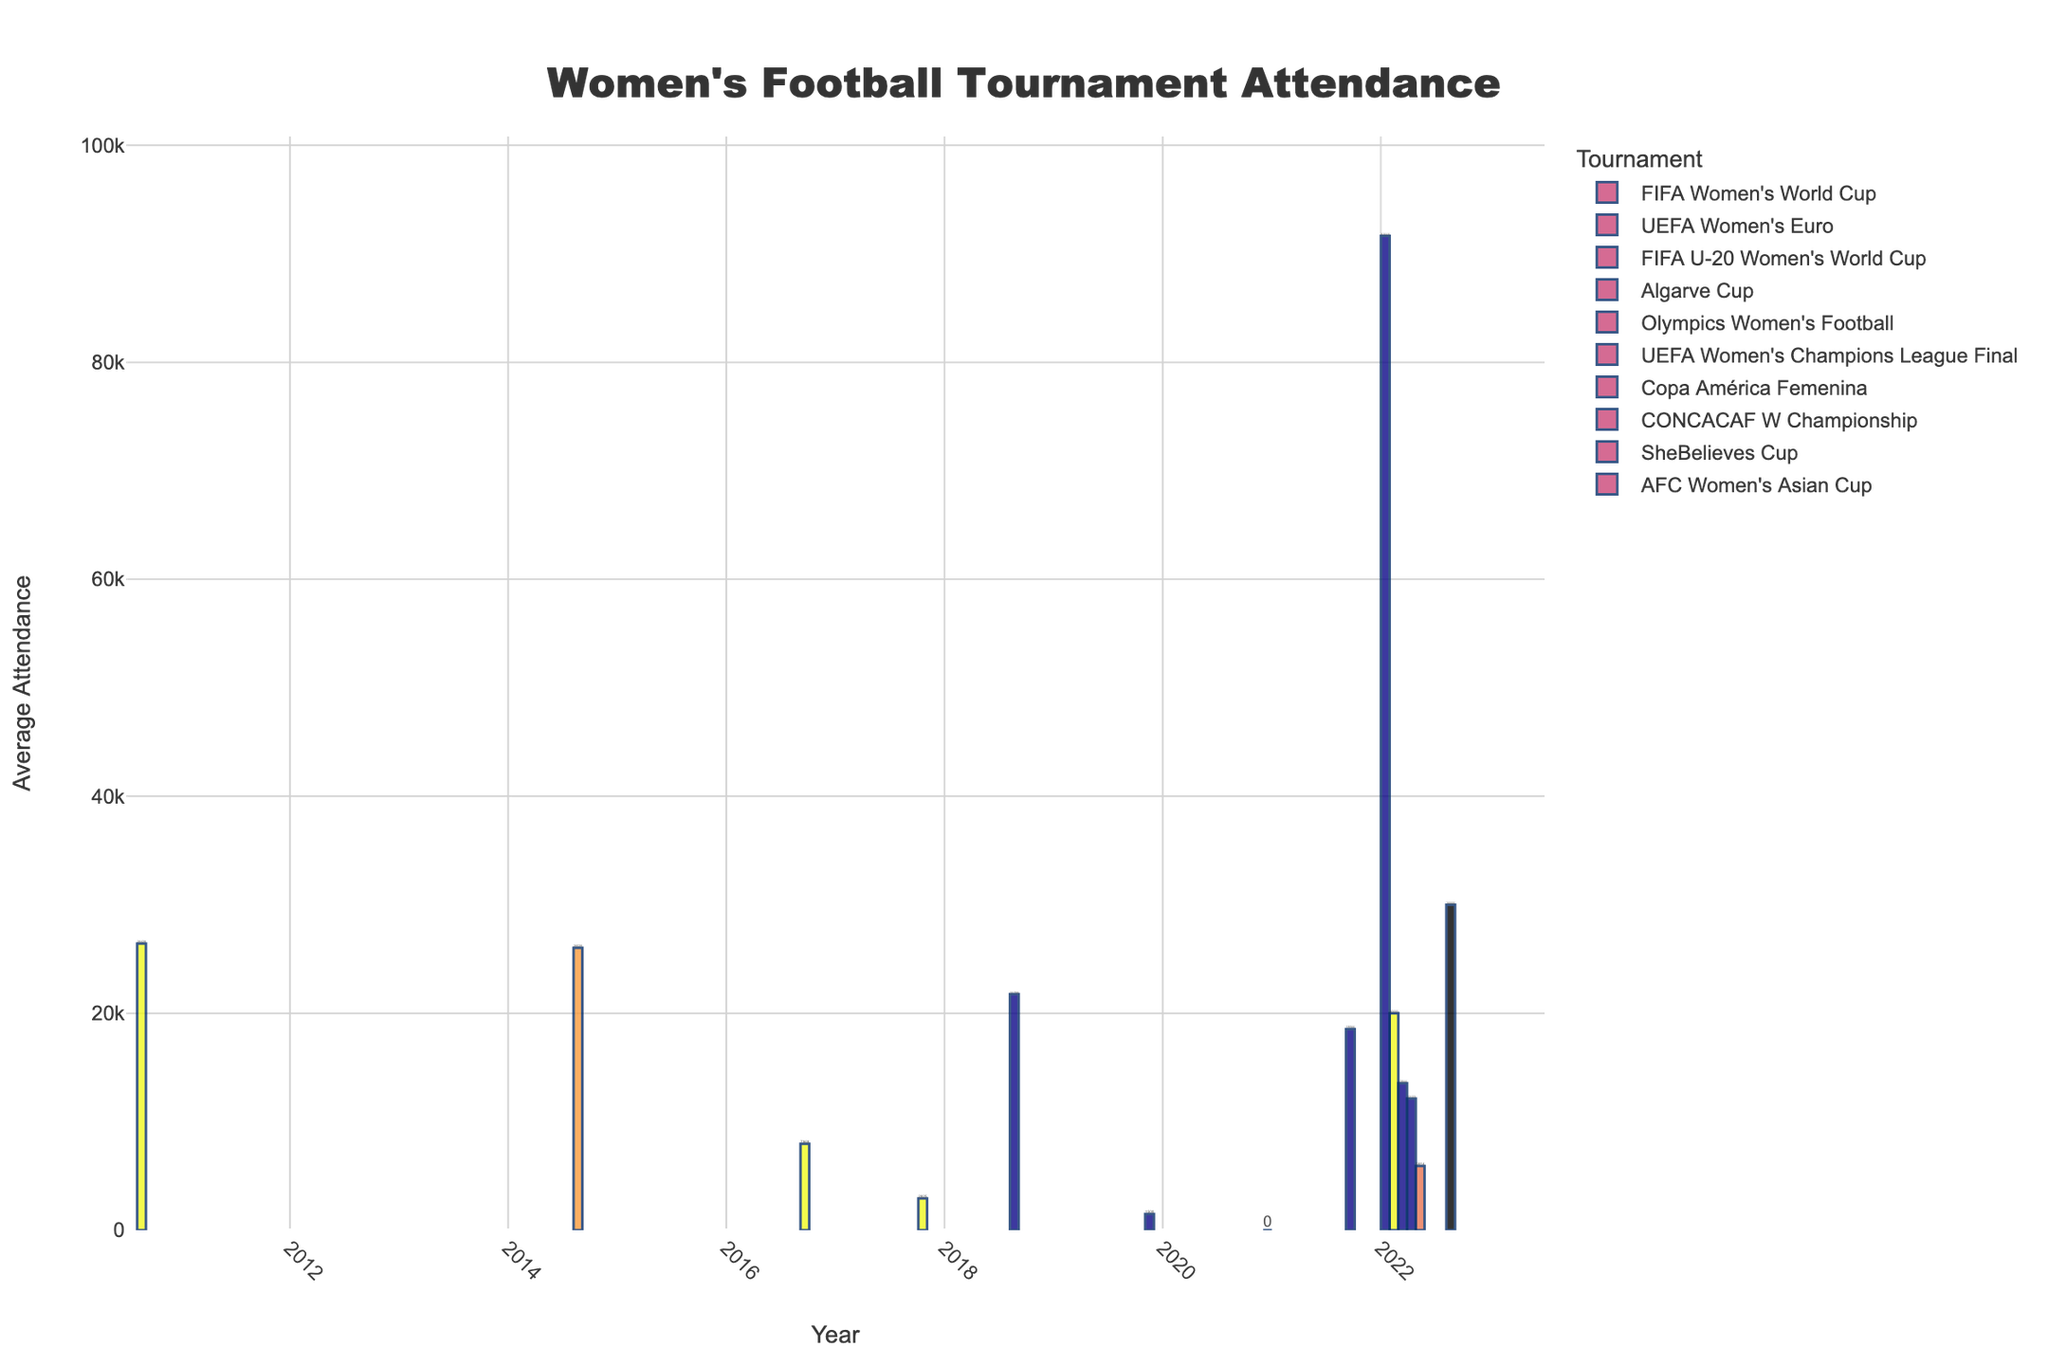What's the highest average attendance for any tournament? Look at the bar with the greatest height, representing the top attendance figure. From the figure, the highest bar corresponds to the UEFA Women's Champions League Final, 2022, with an average attendance of 91,648.
Answer: 91,648 Between the FIFA Women's World Cup 2015 and 2019, which had a higher average attendance, and by how much? Compare the heights of the bars for FIFA Women's World Cup 2015 and 2019. The 2015 bar is slightly higher than the 2019 bar. Subtract their values: 26,029 (2015) - 21,756 (2019)
Answer: FIFA Women's World Cup 2015 had 4,273 more attendees than in 2019 What was the average attendance for the Copa América Femenina, 2022? Identify the bar labeled "Copa América Femenina" under the year 2022 and read its height, which represents the average attendance.
Answer: 20,000 Which tournament had the lowest average attendance? Identify the shortest bar on the figure. The shortest bar corresponds to the Algarve Cup, 2020, with an average attendance of 1,500.
Answer: Algarve Cup, 2020 In 2022, which tournament had the third lowest average attendance and what was the figure? First, isolate all tournaments in 2022. Then, sort their attendance figures and find the third smallest one. Starting from the lowest: AFC Women's Asian Cup (5,914), Algarve Cup (1,500), SheBelieves Cup (12,123).
Answer: SheBelieves Cup, 12,123 What was the average attendance for the AFC Women's Asian Cup, 2022, and the FIFA U-20 Women's World Cup, 2018 combined? Locate the bars for AFC Women's Asian Cup, 2022 and FIFA U-20 Women's World Cup, 2018 and add their values together: 5,914 (AFC Women's Asian Cup, 2022) + 2,925 (FIFA U-20 Women's World Cup, 2018)
Answer: 8,839 Which year had the highest average attendance across all tournaments? Compare the total of average attendances for each year by scanning all bars in each year. 2022 had the most attendances: UEFA Women's Champions League Final (91,648), UEFA Women's Euro (18,544), CONCACAF W Championship (13,544), Copa América Femenina (20,000), AFC Women's Asian Cup (5,914), SheBelieves Cup (12,123),  2022 combined: 161,773.
Answer: 2022 Are there any tournaments that recorded zero attendance? Yes, check if any bars have a height of zero. The Olympics Women's Football, 2021 had zero attendance.
Answer: Olympics Women's Football, 2021 How does the attendance for the UEFA Women's Euro in 2022 compare to its previous tournament in 2017? Compare the heights of the bars for UEFA Women's Euro in 2022 and 2017. The 2022 bar is significantly higher than the 2017 bar.
Answer: Attendance increased in 2022 Summarize the overall trend in attendance for the FIFA Women's World Cup from 2011 to 2023. Observe the height change of the bars for FIFA Women's World Cup in the years 2011, 2015, 2019, and 2023: 26,428 (2011), 26,029 (2015), 21,756 (2019), 30,000 (2023). The trend shows initially high attendance, a slight drop in 2019, and then a rise in 2023.
Answer: Generally increasing with a dip in 2019 